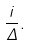<formula> <loc_0><loc_0><loc_500><loc_500>\frac { i } { \Delta } .</formula> 